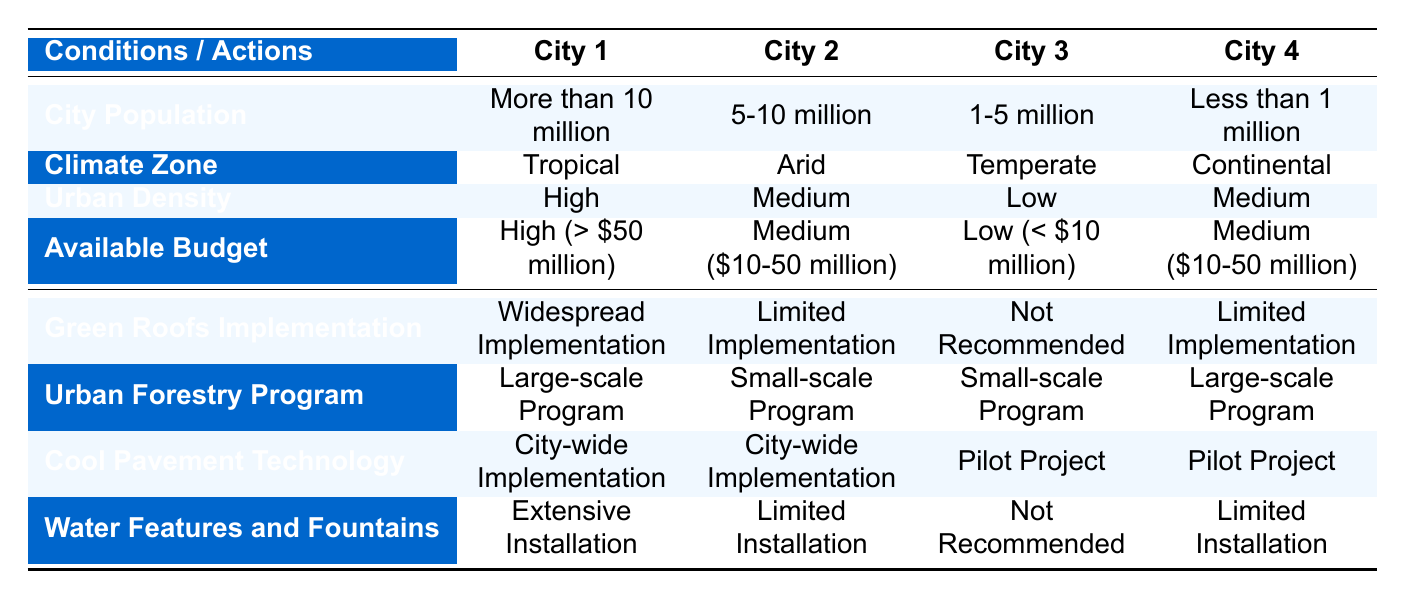What is the recommended implementation for Green Roofs in cities with a population of more than 10 million? According to the table, for cities with a population of more than 10 million, the recommended implementation for Green Roofs is "Widespread Implementation."
Answer: Widespread Implementation Which city has a Medium budget and a Low Urban Density? The table does not list any city that fits the criteria of having a Medium budget and a Low Urban Density. The only city that has a Medium budget is the one with a population of Less than 1 million, but it has a Medium Urban Density instead.
Answer: None Is Urban Forestry Program recommended for cities with Low budgets? The table shows that for cities with Low budgets (less than 10 million), the Urban Forestry Program is recommended as a "Small-scale Program."
Answer: Yes How many cities have a city-wide implementation of Cool Pavement Technology? Both City 2 and City 3 have a city-wide implementation of Cool Pavement Technology according to the table, so there are 2 cities in total.
Answer: 2 What is the difference in the recommendations for Water Features and Fountains between cities with a population of 5-10 million and those with a population of Less than 1 million? For cities with a population of 5-10 million, the recommendation is "Limited Installation" for Water Features and Fountains, while for cities with a population of Less than 1 million it is "Limited Installation" as well. Therefore, there is no difference in recommendations despite the different population sizes.
Answer: No difference Which action is recommended for a city with a Medium budget, Low urban density, and a population of 1-5 million? Examining the table, the city with a Medium budget, Low urban density, and population of 1-5 million has the following recommendations: Green Roofs Implementation is "Not Recommended," Urban Forestry Program is a "Small-scale Program," Cool Pavement Technology is a "Pilot Project," and Water Features and Fountains are "Not Recommended."
Answer: Not Recommended Are any cities recommended for extensive installation of Water Features and Fountains? Yes, the table indicates that for the city with a population of more than 10 million, extensive installation of Water Features and Fountains is recommended.
Answer: Yes What are the recommended strategies for Urban Forestry in cities with high population and high budgets? For cities with a population of more than 10 million and a High budget, the recommended strategy for Urban Forestry Program is a "Large-scale Program."
Answer: Large-scale Program 